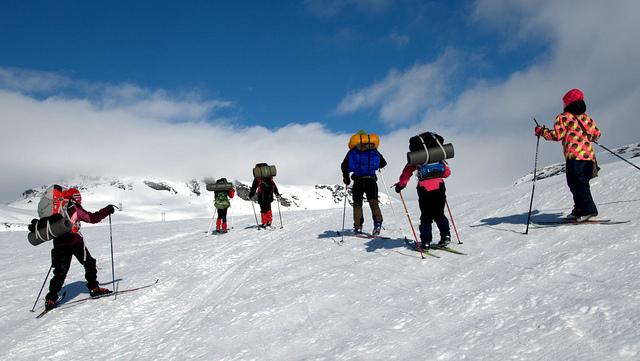How many skiers are going uphill?
Give a very brief answer. 6. How many people are there?
Answer briefly. 6. Is there skis on the people's feet?
Keep it brief. Yes. What type of clouds are pictured?
Short answer required. White. 